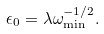<formula> <loc_0><loc_0><loc_500><loc_500>\epsilon _ { 0 } = \lambda \omega _ { \min } ^ { - 1 / 2 } .</formula> 